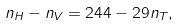<formula> <loc_0><loc_0><loc_500><loc_500>n _ { H } - n _ { V } = 2 4 4 - 2 9 n _ { T } ,</formula> 